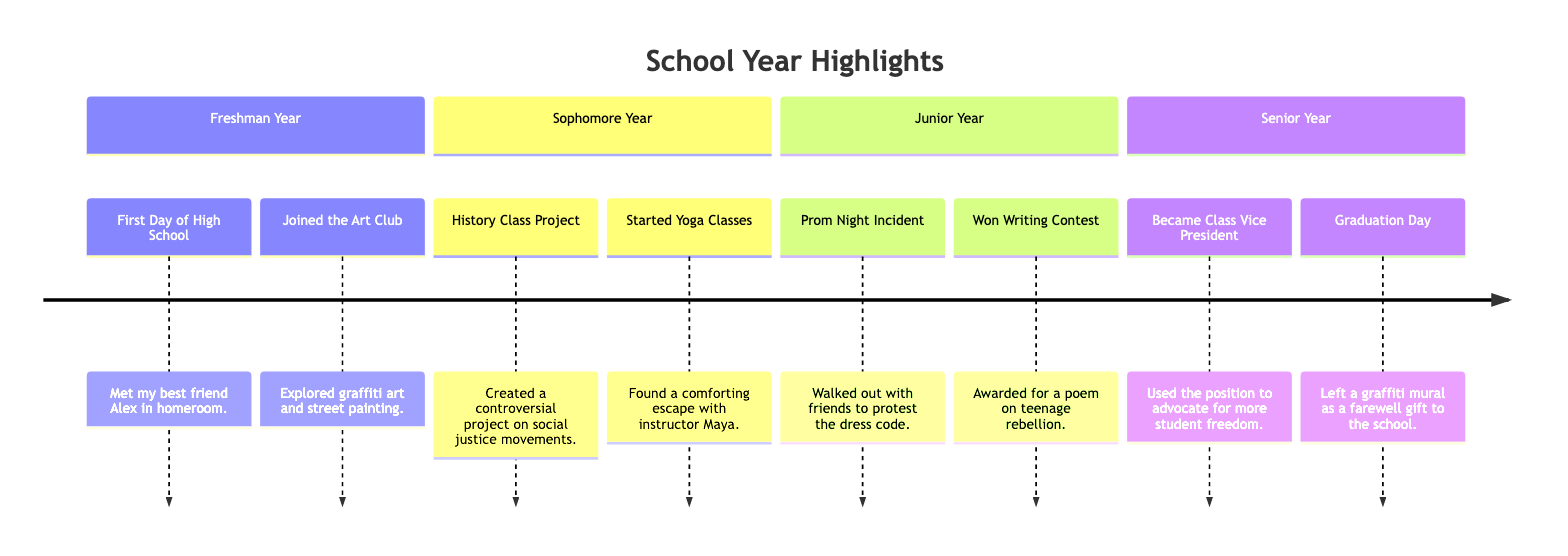What significant event happened during Freshman Year? In Freshman Year, the significant events listed include "First Day of High School" and "Joined the Art Club." Specifically, the event that stands out is "First Day of High School" as it marks the beginning of high school.
Answer: First Day of High School How many events are listed for Senior Year? In the timeline, Senior Year contains two events: "Became Class Vice President" and "Graduation Day." Therefore, the number of events listed for Senior Year is two.
Answer: 2 What was the controversial project about in Sophomore Year? The project created during Sophomore Year is listed as "Created a controversial project on social justice movements." This indicates that the topic of the controversial project was focused on social justice, combining elements of activism and historical perspective.
Answer: social justice movements Which club did you join in Freshman Year? According to the timeline, in Freshman Year, the event "Joined the Art Club" indicates that I became a member of the Art Club. This club allowed exploration of artistic themes such as graffiti art.
Answer: Art Club What was the achievement during Junior Year? In Junior Year, the notable achievement mentioned is "Won Writing Contest." It specifically relates to a poem that was awarded, highlighting a significant accomplishment in writing.
Answer: Won Writing Contest How did the prom night incident relate to self-expression? The "Prom Night Incident" involved "Walked out with friends to protest the dress code," illustrating a clear act of self-expression. It demonstrates a protest against established norms, showcasing a rebellious spirit and desire for freedom of expression among students.
Answer: protest the dress code What did you leave as a farewell gift on Graduation Day? According to the timeline, the event during Graduation Day states "Left a graffiti mural as a farewell gift to the school." This act symbolizes both personal expression and a lasting impact on the school community.
Answer: graffiti mural What role did I take on in Senior Year? The timeline indicates that I "Became Class Vice President" in Senior Year. This role reflects a position of leadership and influence within the school, emphasizing my involvement in school governance.
Answer: Class Vice President What significant activity started in Sophomore Year? The significant activity that began in Sophomore Year is "Started Yoga Classes," which indicates a turn towards personal wellness and coping strategies through yoga with instructor Maya.
Answer: Started Yoga Classes 